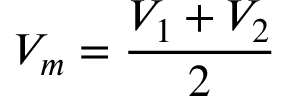<formula> <loc_0><loc_0><loc_500><loc_500>V _ { m } = \frac { V _ { 1 } + V _ { 2 } } { 2 }</formula> 